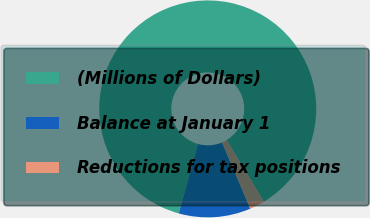Convert chart. <chart><loc_0><loc_0><loc_500><loc_500><pie_chart><fcel>(Millions of Dollars)<fcel>Balance at January 1<fcel>Reductions for tax positions<nl><fcel>87.02%<fcel>10.73%<fcel>2.25%<nl></chart> 